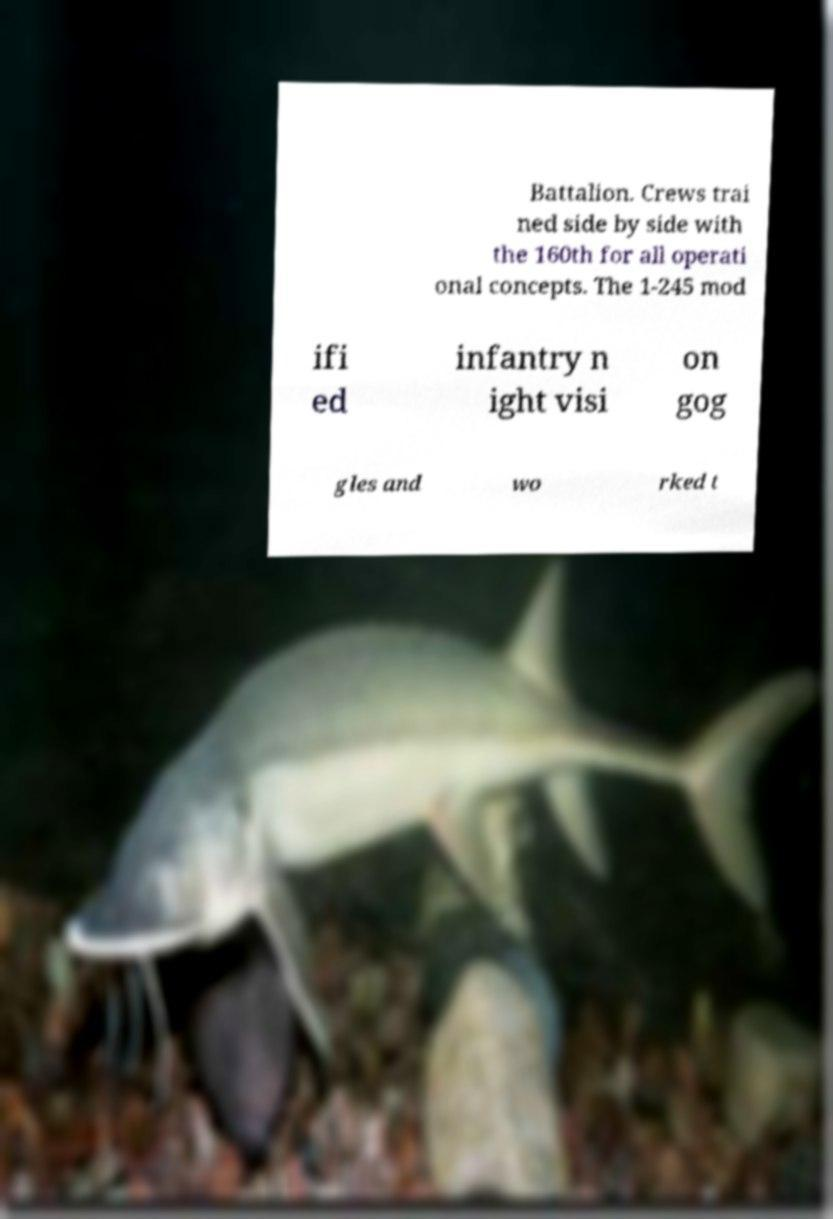There's text embedded in this image that I need extracted. Can you transcribe it verbatim? Battalion. Crews trai ned side by side with the 160th for all operati onal concepts. The 1-245 mod ifi ed infantry n ight visi on gog gles and wo rked t 